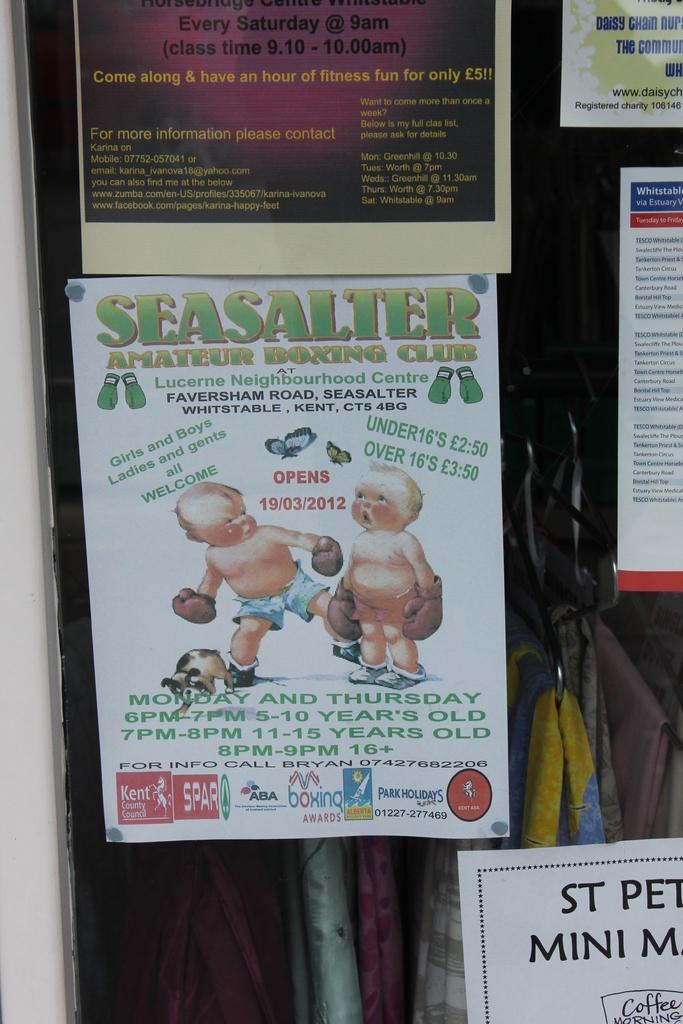Describe this image in one or two sentences. In this picture, we see a glass door on which many posters with text written on it, are pasted on the glass door. Behind that, we see clothes hanged to the hangers and beside the door, we see a white wall. 